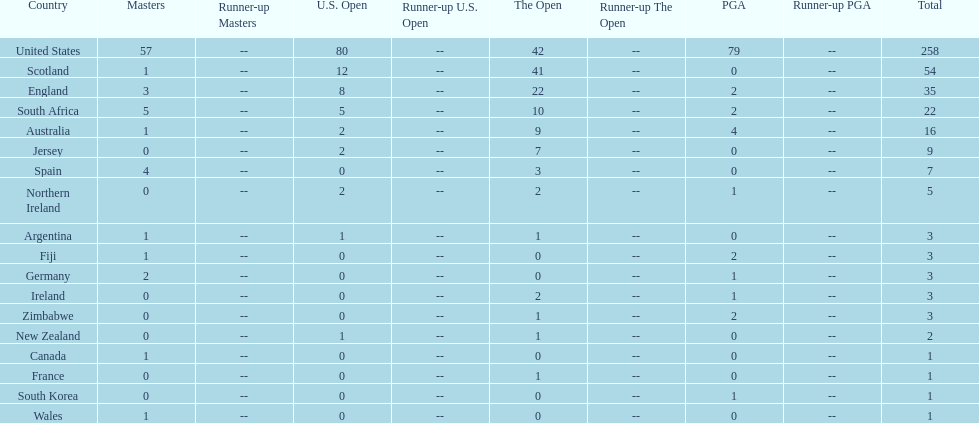What are the number of pga winning golfers that zimbabwe has? 2. 